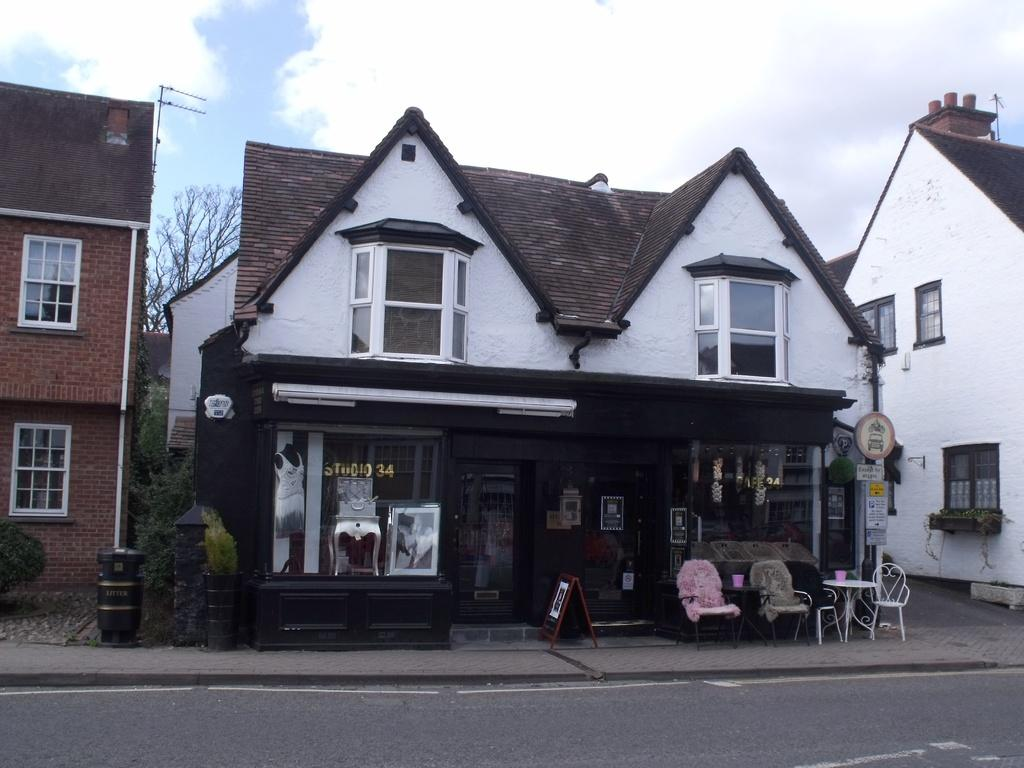What type of furniture is present in the image? There are sitting chairs in the image. What is the primary object on which people might place items or eat? There is a table in the image. What type of structures can be seen in the image? There are houses in the image. What type of objects are present that might be used for displaying information or messages? There are boards in the image. What type of natural vegetation is present in the image? There are trees in the image. What can be seen in the sky in the image? Clouds are visible in the sky in the image. Where is the harbor located in the image? There is no harbor present in the image. What scientific experiment is being conducted in the image? There is no scientific experiment present in the image. 